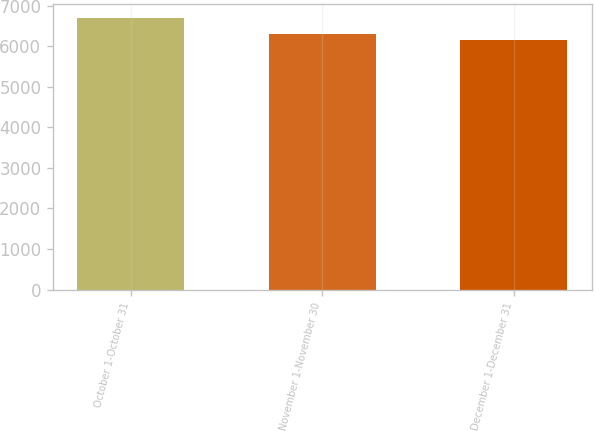Convert chart to OTSL. <chart><loc_0><loc_0><loc_500><loc_500><bar_chart><fcel>October 1-October 31<fcel>November 1-November 30<fcel>December 1-December 31<nl><fcel>6706<fcel>6306<fcel>6154<nl></chart> 